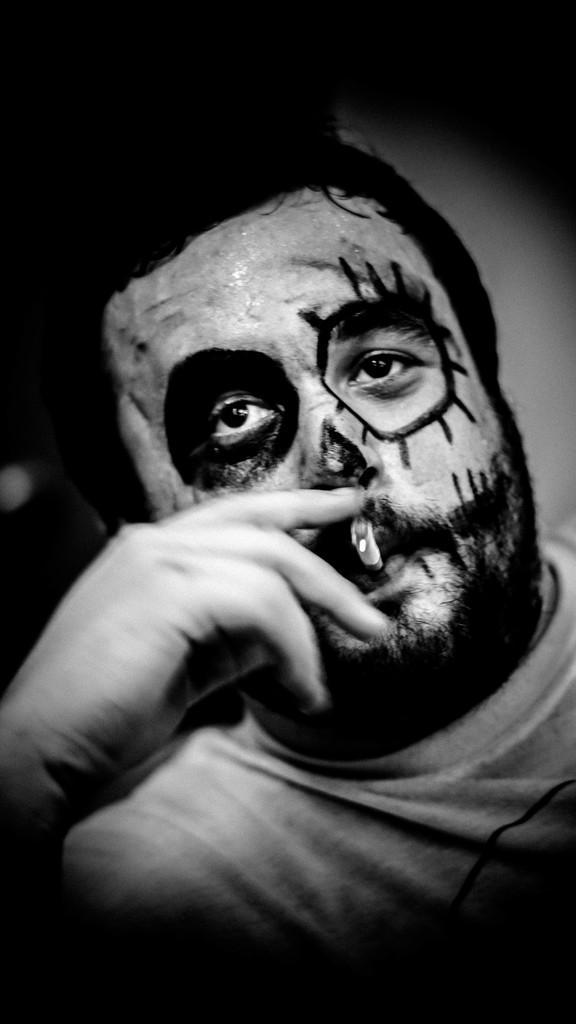Can you describe this image briefly? This is a black and white pic. Here we can see a man smoking and also there is painting on his face. 